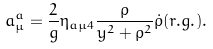Convert formula to latex. <formula><loc_0><loc_0><loc_500><loc_500>a _ { \mu } ^ { a } = \frac { 2 } { g } \eta _ { a \mu 4 } \frac { \rho } { y ^ { 2 } + \rho ^ { 2 } } \dot { \rho } ( { r . g . } ) .</formula> 